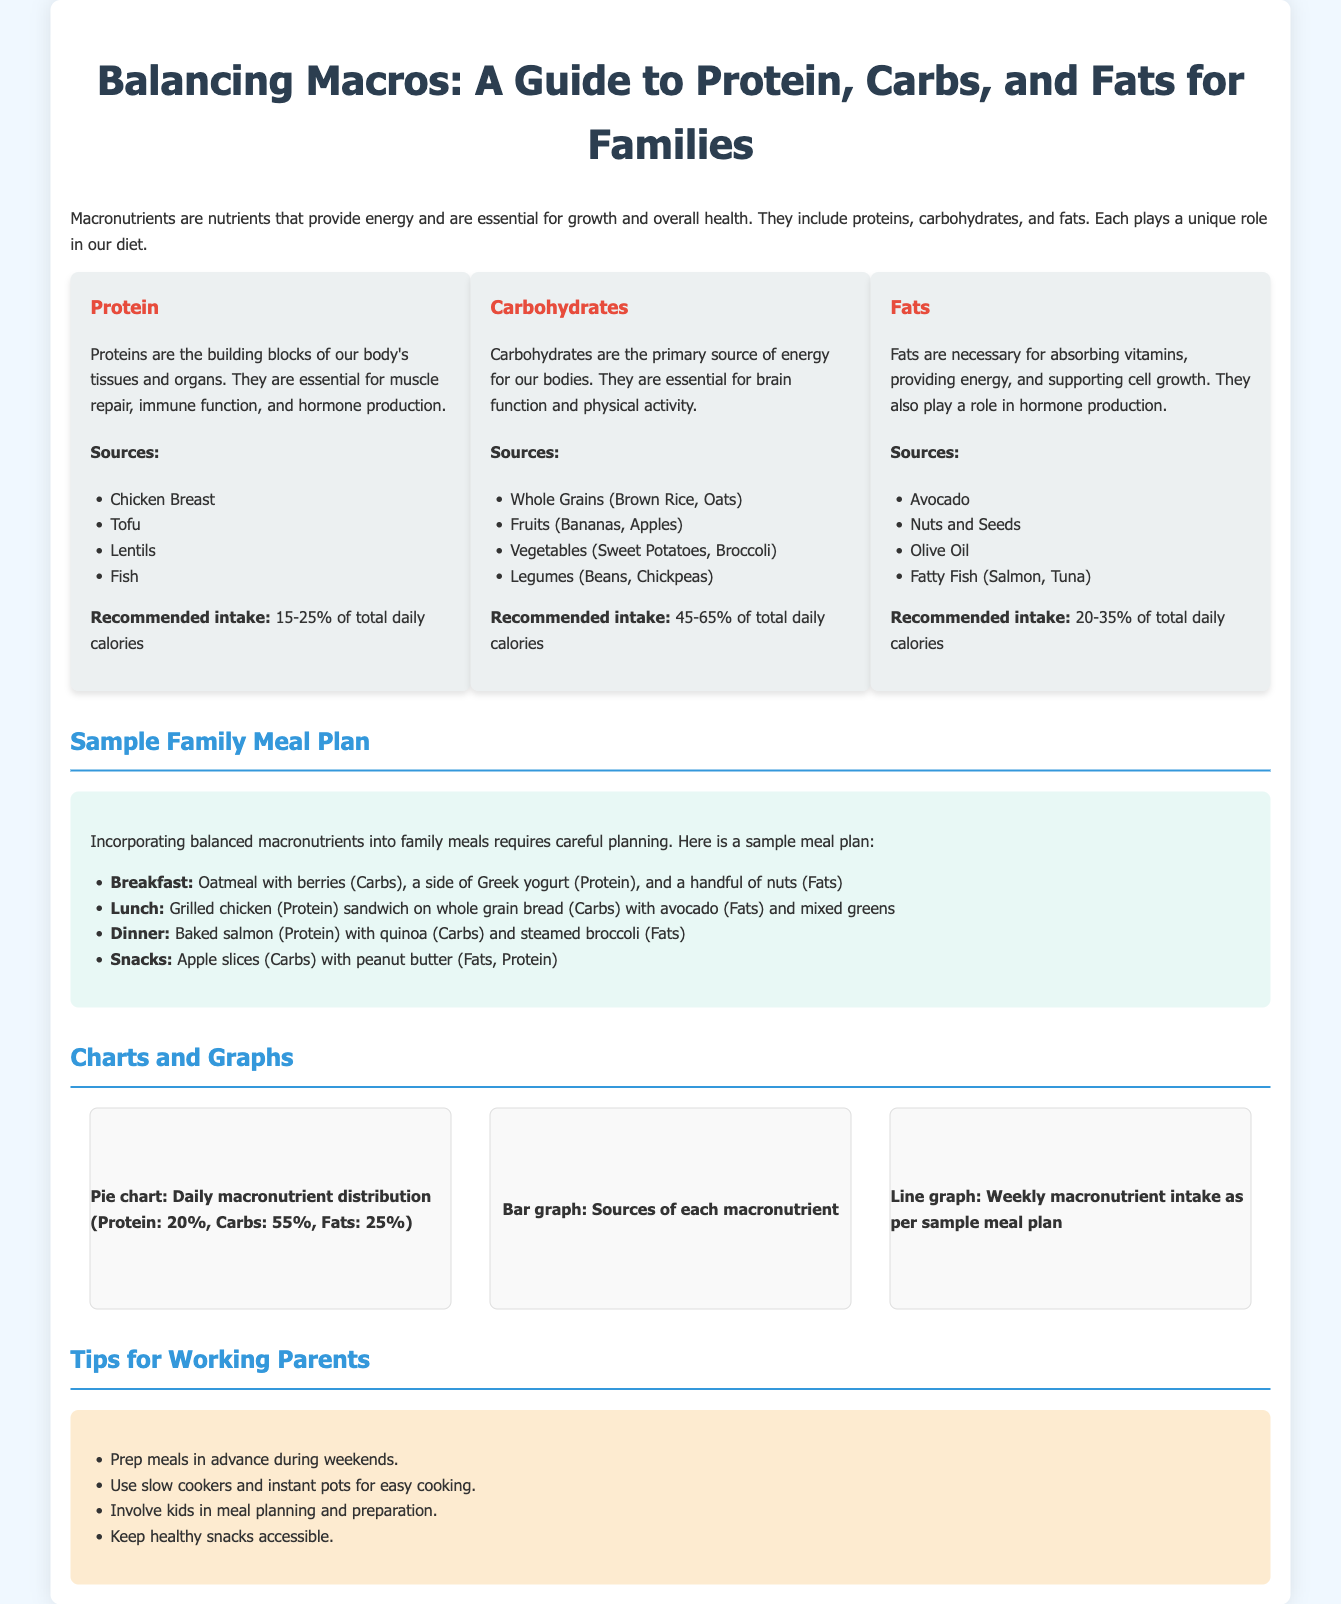What are the three macronutrients? The three macronutrients mentioned in the document are proteins, carbohydrates, and fats.
Answer: proteins, carbohydrates, and fats What is the recommended protein intake percentage? The recommended intake for protein is specified as 15-25% of total daily calories.
Answer: 15-25% Which food is listed as a source of fats? The document lists avocado, nuts and seeds, olive oil, and fatty fish as sources of fats.
Answer: avocado What is the primary source of energy for our bodies? The document states that carbohydrates are the primary source of energy for our bodies.
Answer: carbohydrates How many meals are included in the sample family meal plan? The sample meal plan includes four types of meals: breakfast, lunch, dinner, and snacks.
Answer: four What does the pie chart represent? The pie chart represents the daily macronutrient distribution among proteins, carbohydrates, and fats.
Answer: daily macronutrient distribution Which cooking method is suggested for easy meal preparation? The document suggests using slow cookers and instant pots for easy cooking.
Answer: slow cookers and instant pots What role do fats play in the body according to the document? Fats are necessary for absorbing vitamins, providing energy, and supporting cell growth.
Answer: absorbing vitamins, providing energy, and supporting cell growth What color is used for the section headers? The section headers use a specific color that is light blue (#3498db) according to the document's style.
Answer: light blue 